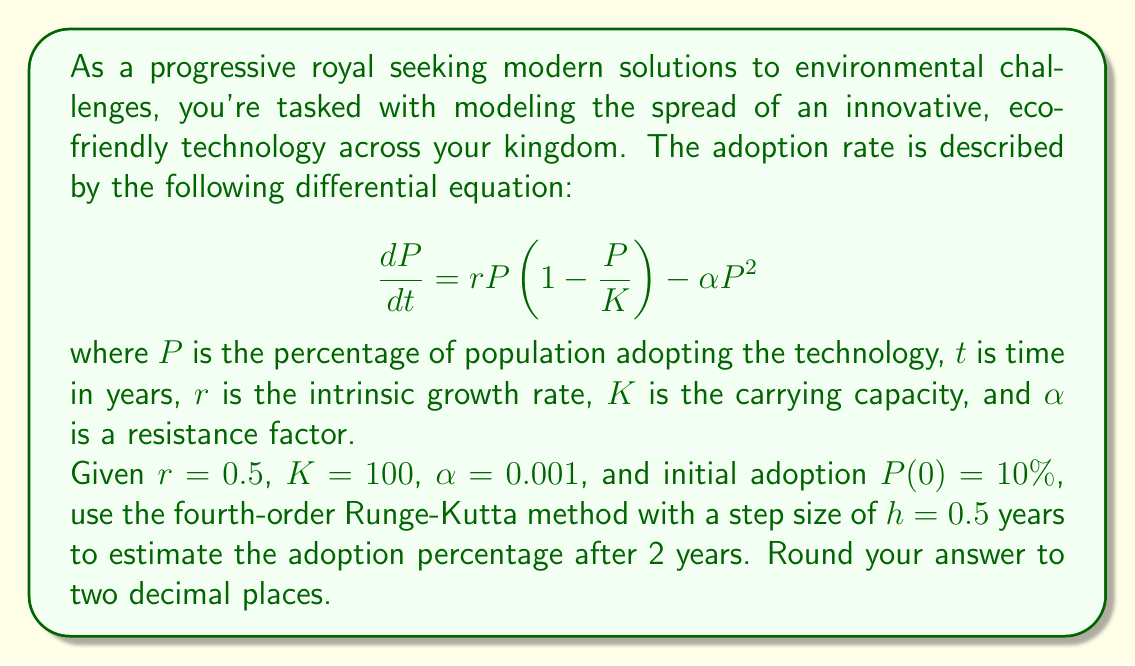Show me your answer to this math problem. To solve this problem, we'll use the fourth-order Runge-Kutta (RK4) method to numerically approximate the solution to the given differential equation. The RK4 method is defined as follows:

$$y_{n+1} = y_n + \frac{1}{6}(k_1 + 2k_2 + 2k_3 + k_4)$$

where:

$$\begin{align*}
k_1 &= hf(t_n, y_n) \\
k_2 &= hf(t_n + \frac{h}{2}, y_n + \frac{k_1}{2}) \\
k_3 &= hf(t_n + \frac{h}{2}, y_n + \frac{k_2}{2}) \\
k_4 &= hf(t_n + h, y_n + k_3)
\end{align*}$$

Our function $f(t, P)$ is:

$$f(t, P) = rP(1-\frac{P}{K}) - \alpha P^2 = 0.5P(1-\frac{P}{100}) - 0.001P^2$$

We need to perform 4 steps with $h=0.5$ to reach $t=2$ years. Let's calculate each step:

Step 1 (t = 0 to 0.5):
$$\begin{align*}
k_1 &= 0.5 \cdot f(0, 10) = 0.5 \cdot (0.5 \cdot 10 \cdot (1-\frac{10}{100}) - 0.001 \cdot 10^2) = 2.225 \\
k_2 &= 0.5 \cdot f(0.25, 10+\frac{2.225}{2}) = 0.5 \cdot f(0.25, 11.1125) = 2.4188 \\
k_3 &= 0.5 \cdot f(0.25, 10+\frac{2.4188}{2}) = 0.5 \cdot f(0.25, 11.2094) = 2.4358 \\
k_4 &= 0.5 \cdot f(0.5, 10+2.4358) = 0.5 \cdot f(0.5, 12.4358) = 2.6411
\end{align*}$$

$$P_1 = 10 + \frac{1}{6}(2.225 + 2 \cdot 2.4188 + 2 \cdot 2.4358 + 2.6411) = 12.4358$$

Step 2 (t = 0.5 to 1):
Repeating the process with $P_1 = 12.4358$, we get $P_2 = 15.1911$

Step 3 (t = 1 to 1.5):
With $P_2 = 15.1911$, we get $P_3 = 18.2506$

Step 4 (t = 1.5 to 2):
With $P_3 = 18.2506$, we get $P_4 = 21.5720$

Therefore, after 2 years, the estimated adoption percentage is 21.57%.
Answer: 21.57% 